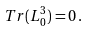<formula> <loc_0><loc_0><loc_500><loc_500>T r ( L _ { 0 } ^ { 3 } ) = 0 \, .</formula> 